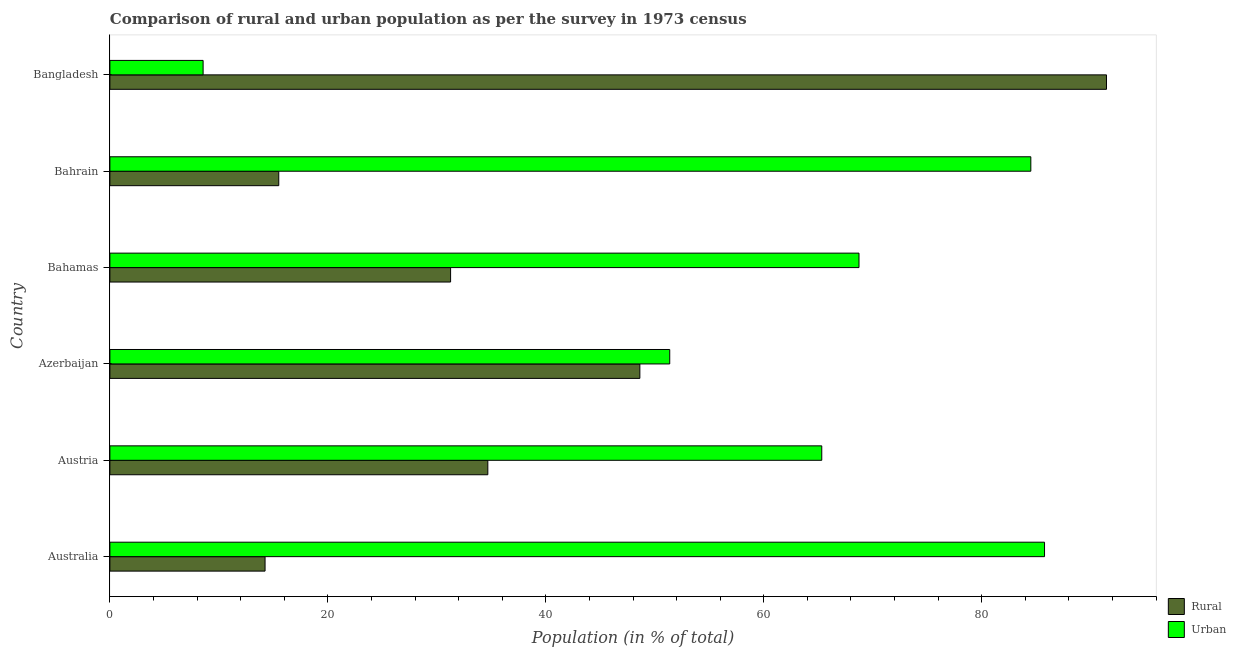How many different coloured bars are there?
Offer a terse response. 2. In how many cases, is the number of bars for a given country not equal to the number of legend labels?
Give a very brief answer. 0. What is the rural population in Australia?
Offer a terse response. 14.24. Across all countries, what is the maximum rural population?
Provide a short and direct response. 91.45. Across all countries, what is the minimum rural population?
Make the answer very short. 14.24. What is the total rural population in the graph?
Make the answer very short. 235.75. What is the difference between the urban population in Australia and that in Bahrain?
Your response must be concise. 1.26. What is the difference between the rural population in Austria and the urban population in Azerbaijan?
Offer a very short reply. -16.69. What is the average urban population per country?
Provide a succinct answer. 60.71. What is the difference between the rural population and urban population in Azerbaijan?
Ensure brevity in your answer.  -2.74. In how many countries, is the urban population greater than 28 %?
Provide a short and direct response. 5. What is the ratio of the rural population in Austria to that in Azerbaijan?
Provide a succinct answer. 0.71. Is the difference between the rural population in Austria and Bahamas greater than the difference between the urban population in Austria and Bahamas?
Offer a terse response. Yes. What is the difference between the highest and the second highest rural population?
Provide a succinct answer. 42.82. What is the difference between the highest and the lowest urban population?
Keep it short and to the point. 77.21. What does the 1st bar from the top in Austria represents?
Provide a succinct answer. Urban. What does the 1st bar from the bottom in Bahamas represents?
Keep it short and to the point. Rural. How many bars are there?
Give a very brief answer. 12. How many countries are there in the graph?
Make the answer very short. 6. What is the difference between two consecutive major ticks on the X-axis?
Provide a succinct answer. 20. Are the values on the major ticks of X-axis written in scientific E-notation?
Offer a very short reply. No. Does the graph contain grids?
Provide a succinct answer. No. Where does the legend appear in the graph?
Make the answer very short. Bottom right. How many legend labels are there?
Offer a terse response. 2. How are the legend labels stacked?
Your answer should be very brief. Vertical. What is the title of the graph?
Give a very brief answer. Comparison of rural and urban population as per the survey in 1973 census. Does "Largest city" appear as one of the legend labels in the graph?
Make the answer very short. No. What is the label or title of the X-axis?
Give a very brief answer. Population (in % of total). What is the Population (in % of total) of Rural in Australia?
Provide a short and direct response. 14.24. What is the Population (in % of total) in Urban in Australia?
Offer a terse response. 85.76. What is the Population (in % of total) of Rural in Austria?
Ensure brevity in your answer.  34.68. What is the Population (in % of total) in Urban in Austria?
Ensure brevity in your answer.  65.32. What is the Population (in % of total) in Rural in Azerbaijan?
Make the answer very short. 48.63. What is the Population (in % of total) of Urban in Azerbaijan?
Offer a terse response. 51.37. What is the Population (in % of total) in Rural in Bahamas?
Make the answer very short. 31.26. What is the Population (in % of total) in Urban in Bahamas?
Offer a terse response. 68.74. What is the Population (in % of total) of Rural in Bahrain?
Offer a terse response. 15.5. What is the Population (in % of total) in Urban in Bahrain?
Your answer should be compact. 84.5. What is the Population (in % of total) of Rural in Bangladesh?
Offer a terse response. 91.45. What is the Population (in % of total) of Urban in Bangladesh?
Your answer should be compact. 8.55. Across all countries, what is the maximum Population (in % of total) of Rural?
Make the answer very short. 91.45. Across all countries, what is the maximum Population (in % of total) of Urban?
Offer a very short reply. 85.76. Across all countries, what is the minimum Population (in % of total) of Rural?
Your answer should be compact. 14.24. Across all countries, what is the minimum Population (in % of total) in Urban?
Offer a terse response. 8.55. What is the total Population (in % of total) of Rural in the graph?
Provide a short and direct response. 235.75. What is the total Population (in % of total) in Urban in the graph?
Ensure brevity in your answer.  364.25. What is the difference between the Population (in % of total) in Rural in Australia and that in Austria?
Give a very brief answer. -20.44. What is the difference between the Population (in % of total) in Urban in Australia and that in Austria?
Offer a very short reply. 20.44. What is the difference between the Population (in % of total) in Rural in Australia and that in Azerbaijan?
Ensure brevity in your answer.  -34.39. What is the difference between the Population (in % of total) in Urban in Australia and that in Azerbaijan?
Offer a terse response. 34.39. What is the difference between the Population (in % of total) of Rural in Australia and that in Bahamas?
Your answer should be compact. -17.02. What is the difference between the Population (in % of total) of Urban in Australia and that in Bahamas?
Give a very brief answer. 17.02. What is the difference between the Population (in % of total) in Rural in Australia and that in Bahrain?
Your answer should be very brief. -1.26. What is the difference between the Population (in % of total) in Urban in Australia and that in Bahrain?
Provide a succinct answer. 1.26. What is the difference between the Population (in % of total) in Rural in Australia and that in Bangladesh?
Your response must be concise. -77.21. What is the difference between the Population (in % of total) in Urban in Australia and that in Bangladesh?
Provide a succinct answer. 77.21. What is the difference between the Population (in % of total) of Rural in Austria and that in Azerbaijan?
Your answer should be compact. -13.95. What is the difference between the Population (in % of total) of Urban in Austria and that in Azerbaijan?
Your response must be concise. 13.95. What is the difference between the Population (in % of total) of Rural in Austria and that in Bahamas?
Ensure brevity in your answer.  3.42. What is the difference between the Population (in % of total) of Urban in Austria and that in Bahamas?
Provide a succinct answer. -3.42. What is the difference between the Population (in % of total) in Rural in Austria and that in Bahrain?
Your answer should be compact. 19.18. What is the difference between the Population (in % of total) in Urban in Austria and that in Bahrain?
Give a very brief answer. -19.18. What is the difference between the Population (in % of total) in Rural in Austria and that in Bangladesh?
Offer a terse response. -56.77. What is the difference between the Population (in % of total) in Urban in Austria and that in Bangladesh?
Your answer should be compact. 56.77. What is the difference between the Population (in % of total) of Rural in Azerbaijan and that in Bahamas?
Offer a very short reply. 17.37. What is the difference between the Population (in % of total) in Urban in Azerbaijan and that in Bahamas?
Provide a succinct answer. -17.37. What is the difference between the Population (in % of total) of Rural in Azerbaijan and that in Bahrain?
Offer a terse response. 33.13. What is the difference between the Population (in % of total) in Urban in Azerbaijan and that in Bahrain?
Make the answer very short. -33.13. What is the difference between the Population (in % of total) of Rural in Azerbaijan and that in Bangladesh?
Ensure brevity in your answer.  -42.82. What is the difference between the Population (in % of total) in Urban in Azerbaijan and that in Bangladesh?
Make the answer very short. 42.82. What is the difference between the Population (in % of total) in Rural in Bahamas and that in Bahrain?
Provide a succinct answer. 15.77. What is the difference between the Population (in % of total) of Urban in Bahamas and that in Bahrain?
Give a very brief answer. -15.77. What is the difference between the Population (in % of total) of Rural in Bahamas and that in Bangladesh?
Provide a succinct answer. -60.19. What is the difference between the Population (in % of total) of Urban in Bahamas and that in Bangladesh?
Offer a very short reply. 60.19. What is the difference between the Population (in % of total) in Rural in Bahrain and that in Bangladesh?
Offer a terse response. -75.95. What is the difference between the Population (in % of total) of Urban in Bahrain and that in Bangladesh?
Offer a terse response. 75.95. What is the difference between the Population (in % of total) of Rural in Australia and the Population (in % of total) of Urban in Austria?
Your answer should be compact. -51.08. What is the difference between the Population (in % of total) in Rural in Australia and the Population (in % of total) in Urban in Azerbaijan?
Your response must be concise. -37.13. What is the difference between the Population (in % of total) in Rural in Australia and the Population (in % of total) in Urban in Bahamas?
Provide a succinct answer. -54.5. What is the difference between the Population (in % of total) in Rural in Australia and the Population (in % of total) in Urban in Bahrain?
Provide a short and direct response. -70.27. What is the difference between the Population (in % of total) in Rural in Australia and the Population (in % of total) in Urban in Bangladesh?
Offer a terse response. 5.69. What is the difference between the Population (in % of total) of Rural in Austria and the Population (in % of total) of Urban in Azerbaijan?
Keep it short and to the point. -16.69. What is the difference between the Population (in % of total) in Rural in Austria and the Population (in % of total) in Urban in Bahamas?
Offer a terse response. -34.06. What is the difference between the Population (in % of total) of Rural in Austria and the Population (in % of total) of Urban in Bahrain?
Make the answer very short. -49.83. What is the difference between the Population (in % of total) of Rural in Austria and the Population (in % of total) of Urban in Bangladesh?
Offer a very short reply. 26.13. What is the difference between the Population (in % of total) of Rural in Azerbaijan and the Population (in % of total) of Urban in Bahamas?
Keep it short and to the point. -20.11. What is the difference between the Population (in % of total) of Rural in Azerbaijan and the Population (in % of total) of Urban in Bahrain?
Provide a succinct answer. -35.88. What is the difference between the Population (in % of total) in Rural in Azerbaijan and the Population (in % of total) in Urban in Bangladesh?
Provide a short and direct response. 40.08. What is the difference between the Population (in % of total) of Rural in Bahamas and the Population (in % of total) of Urban in Bahrain?
Your answer should be compact. -53.24. What is the difference between the Population (in % of total) in Rural in Bahamas and the Population (in % of total) in Urban in Bangladesh?
Offer a very short reply. 22.71. What is the difference between the Population (in % of total) in Rural in Bahrain and the Population (in % of total) in Urban in Bangladesh?
Your answer should be compact. 6.94. What is the average Population (in % of total) of Rural per country?
Your answer should be compact. 39.29. What is the average Population (in % of total) of Urban per country?
Provide a succinct answer. 60.71. What is the difference between the Population (in % of total) in Rural and Population (in % of total) in Urban in Australia?
Your response must be concise. -71.52. What is the difference between the Population (in % of total) in Rural and Population (in % of total) in Urban in Austria?
Your response must be concise. -30.64. What is the difference between the Population (in % of total) in Rural and Population (in % of total) in Urban in Azerbaijan?
Provide a succinct answer. -2.74. What is the difference between the Population (in % of total) of Rural and Population (in % of total) of Urban in Bahamas?
Offer a terse response. -37.48. What is the difference between the Population (in % of total) of Rural and Population (in % of total) of Urban in Bahrain?
Provide a succinct answer. -69.01. What is the difference between the Population (in % of total) in Rural and Population (in % of total) in Urban in Bangladesh?
Ensure brevity in your answer.  82.89. What is the ratio of the Population (in % of total) in Rural in Australia to that in Austria?
Provide a succinct answer. 0.41. What is the ratio of the Population (in % of total) in Urban in Australia to that in Austria?
Offer a terse response. 1.31. What is the ratio of the Population (in % of total) of Rural in Australia to that in Azerbaijan?
Keep it short and to the point. 0.29. What is the ratio of the Population (in % of total) of Urban in Australia to that in Azerbaijan?
Keep it short and to the point. 1.67. What is the ratio of the Population (in % of total) in Rural in Australia to that in Bahamas?
Provide a succinct answer. 0.46. What is the ratio of the Population (in % of total) in Urban in Australia to that in Bahamas?
Provide a short and direct response. 1.25. What is the ratio of the Population (in % of total) of Rural in Australia to that in Bahrain?
Offer a terse response. 0.92. What is the ratio of the Population (in % of total) of Urban in Australia to that in Bahrain?
Provide a succinct answer. 1.01. What is the ratio of the Population (in % of total) of Rural in Australia to that in Bangladesh?
Make the answer very short. 0.16. What is the ratio of the Population (in % of total) in Urban in Australia to that in Bangladesh?
Keep it short and to the point. 10.03. What is the ratio of the Population (in % of total) in Rural in Austria to that in Azerbaijan?
Your response must be concise. 0.71. What is the ratio of the Population (in % of total) of Urban in Austria to that in Azerbaijan?
Your answer should be very brief. 1.27. What is the ratio of the Population (in % of total) in Rural in Austria to that in Bahamas?
Make the answer very short. 1.11. What is the ratio of the Population (in % of total) in Urban in Austria to that in Bahamas?
Your answer should be compact. 0.95. What is the ratio of the Population (in % of total) of Rural in Austria to that in Bahrain?
Offer a very short reply. 2.24. What is the ratio of the Population (in % of total) in Urban in Austria to that in Bahrain?
Your answer should be very brief. 0.77. What is the ratio of the Population (in % of total) in Rural in Austria to that in Bangladesh?
Ensure brevity in your answer.  0.38. What is the ratio of the Population (in % of total) of Urban in Austria to that in Bangladesh?
Your answer should be compact. 7.64. What is the ratio of the Population (in % of total) in Rural in Azerbaijan to that in Bahamas?
Ensure brevity in your answer.  1.56. What is the ratio of the Population (in % of total) in Urban in Azerbaijan to that in Bahamas?
Provide a succinct answer. 0.75. What is the ratio of the Population (in % of total) of Rural in Azerbaijan to that in Bahrain?
Ensure brevity in your answer.  3.14. What is the ratio of the Population (in % of total) in Urban in Azerbaijan to that in Bahrain?
Provide a succinct answer. 0.61. What is the ratio of the Population (in % of total) in Rural in Azerbaijan to that in Bangladesh?
Make the answer very short. 0.53. What is the ratio of the Population (in % of total) in Urban in Azerbaijan to that in Bangladesh?
Make the answer very short. 6.01. What is the ratio of the Population (in % of total) in Rural in Bahamas to that in Bahrain?
Offer a terse response. 2.02. What is the ratio of the Population (in % of total) of Urban in Bahamas to that in Bahrain?
Your answer should be compact. 0.81. What is the ratio of the Population (in % of total) in Rural in Bahamas to that in Bangladesh?
Your response must be concise. 0.34. What is the ratio of the Population (in % of total) of Urban in Bahamas to that in Bangladesh?
Keep it short and to the point. 8.04. What is the ratio of the Population (in % of total) of Rural in Bahrain to that in Bangladesh?
Your response must be concise. 0.17. What is the ratio of the Population (in % of total) of Urban in Bahrain to that in Bangladesh?
Offer a very short reply. 9.88. What is the difference between the highest and the second highest Population (in % of total) of Rural?
Provide a succinct answer. 42.82. What is the difference between the highest and the second highest Population (in % of total) of Urban?
Offer a terse response. 1.26. What is the difference between the highest and the lowest Population (in % of total) in Rural?
Keep it short and to the point. 77.21. What is the difference between the highest and the lowest Population (in % of total) in Urban?
Keep it short and to the point. 77.21. 